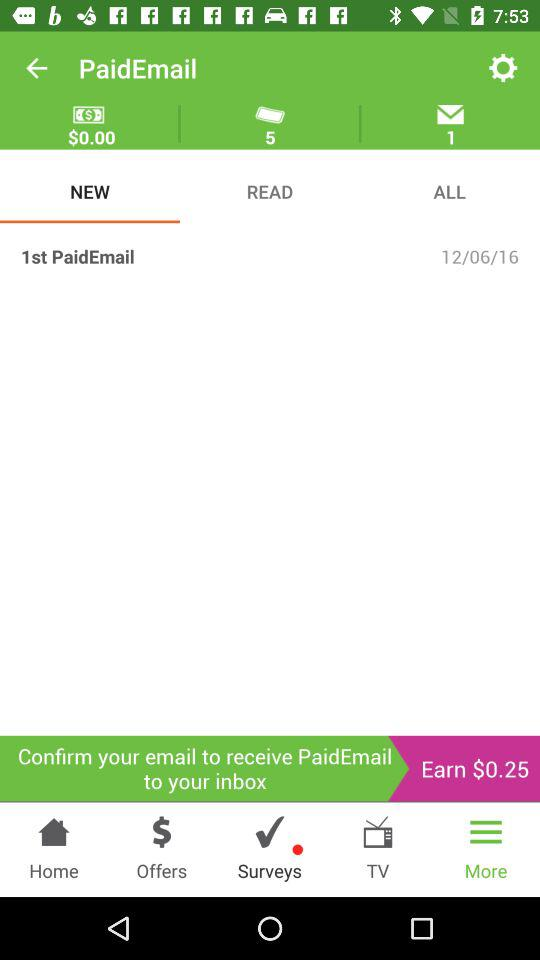How much is the total amount of money earned?
Answer the question using a single word or phrase. $0.25 